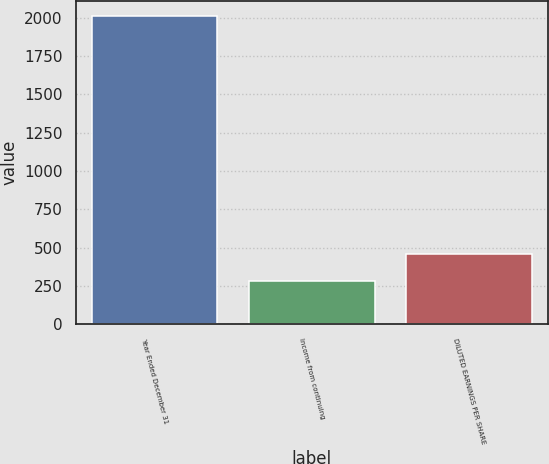Convert chart. <chart><loc_0><loc_0><loc_500><loc_500><bar_chart><fcel>Year Ended December 31<fcel>Income from continuing<fcel>DILUTED EARNINGS PER SHARE<nl><fcel>2013<fcel>284<fcel>456.9<nl></chart> 